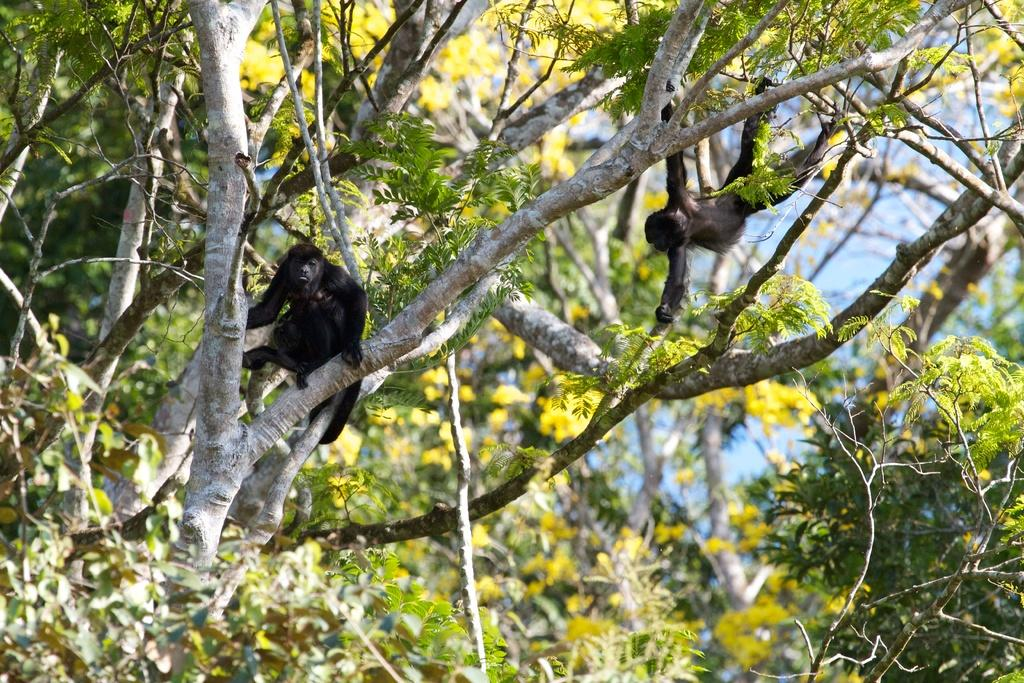What type of animals are in the image? There are apes in the image. Where are the apes located in the image? The apes are on the branches of trees. What can be seen in the background of the image? There is sky visible in the background of the image. What type of blood is visible on the apes in the image? There is no blood visible on the apes in the image. What religious symbol can be seen in the image? There is no religious symbol present in the image. 